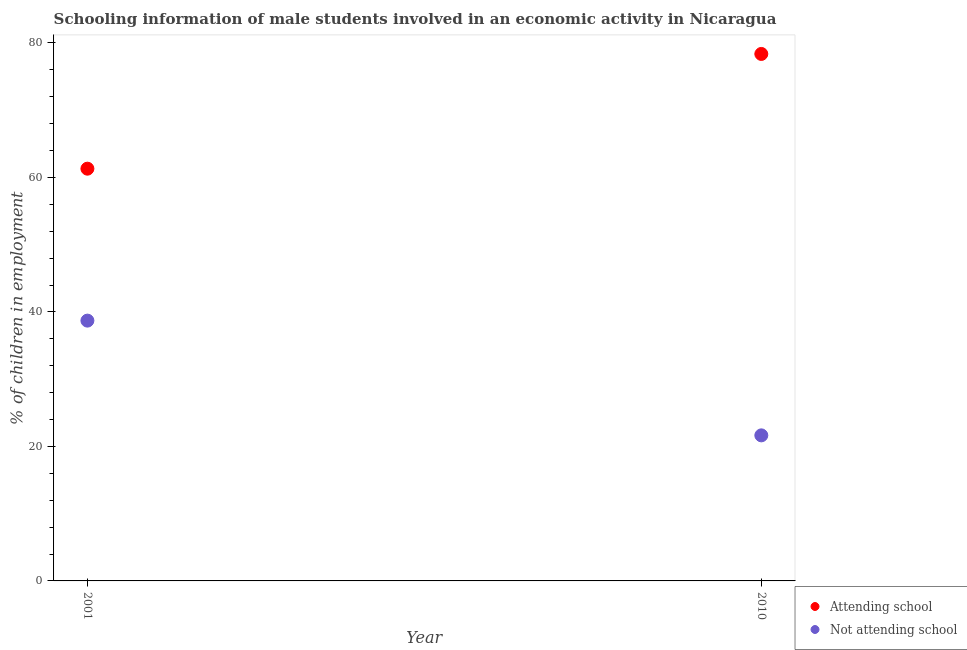Is the number of dotlines equal to the number of legend labels?
Provide a short and direct response. Yes. What is the percentage of employed males who are not attending school in 2010?
Your response must be concise. 21.64. Across all years, what is the maximum percentage of employed males who are not attending school?
Make the answer very short. 38.7. Across all years, what is the minimum percentage of employed males who are not attending school?
Give a very brief answer. 21.64. In which year was the percentage of employed males who are not attending school maximum?
Provide a succinct answer. 2001. What is the total percentage of employed males who are attending school in the graph?
Provide a short and direct response. 139.65. What is the difference between the percentage of employed males who are attending school in 2001 and that in 2010?
Offer a terse response. -17.06. What is the difference between the percentage of employed males who are attending school in 2001 and the percentage of employed males who are not attending school in 2010?
Provide a succinct answer. 39.65. What is the average percentage of employed males who are not attending school per year?
Provide a short and direct response. 30.17. In the year 2010, what is the difference between the percentage of employed males who are attending school and percentage of employed males who are not attending school?
Your answer should be compact. 56.71. In how many years, is the percentage of employed males who are not attending school greater than 64 %?
Give a very brief answer. 0. What is the ratio of the percentage of employed males who are not attending school in 2001 to that in 2010?
Ensure brevity in your answer.  1.79. Does the percentage of employed males who are not attending school monotonically increase over the years?
Provide a succinct answer. No. Is the percentage of employed males who are not attending school strictly greater than the percentage of employed males who are attending school over the years?
Provide a short and direct response. No. Is the percentage of employed males who are not attending school strictly less than the percentage of employed males who are attending school over the years?
Provide a short and direct response. Yes. How many dotlines are there?
Your answer should be very brief. 2. Are the values on the major ticks of Y-axis written in scientific E-notation?
Make the answer very short. No. Does the graph contain any zero values?
Your response must be concise. No. Does the graph contain grids?
Your answer should be very brief. No. How many legend labels are there?
Offer a terse response. 2. What is the title of the graph?
Offer a very short reply. Schooling information of male students involved in an economic activity in Nicaragua. What is the label or title of the X-axis?
Offer a very short reply. Year. What is the label or title of the Y-axis?
Ensure brevity in your answer.  % of children in employment. What is the % of children in employment of Attending school in 2001?
Give a very brief answer. 61.3. What is the % of children in employment in Not attending school in 2001?
Make the answer very short. 38.7. What is the % of children in employment in Attending school in 2010?
Make the answer very short. 78.36. What is the % of children in employment in Not attending school in 2010?
Offer a terse response. 21.64. Across all years, what is the maximum % of children in employment in Attending school?
Offer a very short reply. 78.36. Across all years, what is the maximum % of children in employment in Not attending school?
Ensure brevity in your answer.  38.7. Across all years, what is the minimum % of children in employment in Attending school?
Offer a terse response. 61.3. Across all years, what is the minimum % of children in employment of Not attending school?
Keep it short and to the point. 21.64. What is the total % of children in employment in Attending school in the graph?
Keep it short and to the point. 139.65. What is the total % of children in employment in Not attending school in the graph?
Your answer should be compact. 60.35. What is the difference between the % of children in employment of Attending school in 2001 and that in 2010?
Ensure brevity in your answer.  -17.06. What is the difference between the % of children in employment of Not attending school in 2001 and that in 2010?
Make the answer very short. 17.06. What is the difference between the % of children in employment of Attending school in 2001 and the % of children in employment of Not attending school in 2010?
Your answer should be compact. 39.65. What is the average % of children in employment of Attending school per year?
Your answer should be compact. 69.83. What is the average % of children in employment in Not attending school per year?
Your answer should be compact. 30.17. In the year 2001, what is the difference between the % of children in employment of Attending school and % of children in employment of Not attending school?
Provide a succinct answer. 22.59. In the year 2010, what is the difference between the % of children in employment of Attending school and % of children in employment of Not attending school?
Offer a terse response. 56.71. What is the ratio of the % of children in employment of Attending school in 2001 to that in 2010?
Make the answer very short. 0.78. What is the ratio of the % of children in employment of Not attending school in 2001 to that in 2010?
Give a very brief answer. 1.79. What is the difference between the highest and the second highest % of children in employment in Attending school?
Your response must be concise. 17.06. What is the difference between the highest and the second highest % of children in employment in Not attending school?
Provide a short and direct response. 17.06. What is the difference between the highest and the lowest % of children in employment in Attending school?
Your response must be concise. 17.06. What is the difference between the highest and the lowest % of children in employment of Not attending school?
Your answer should be very brief. 17.06. 